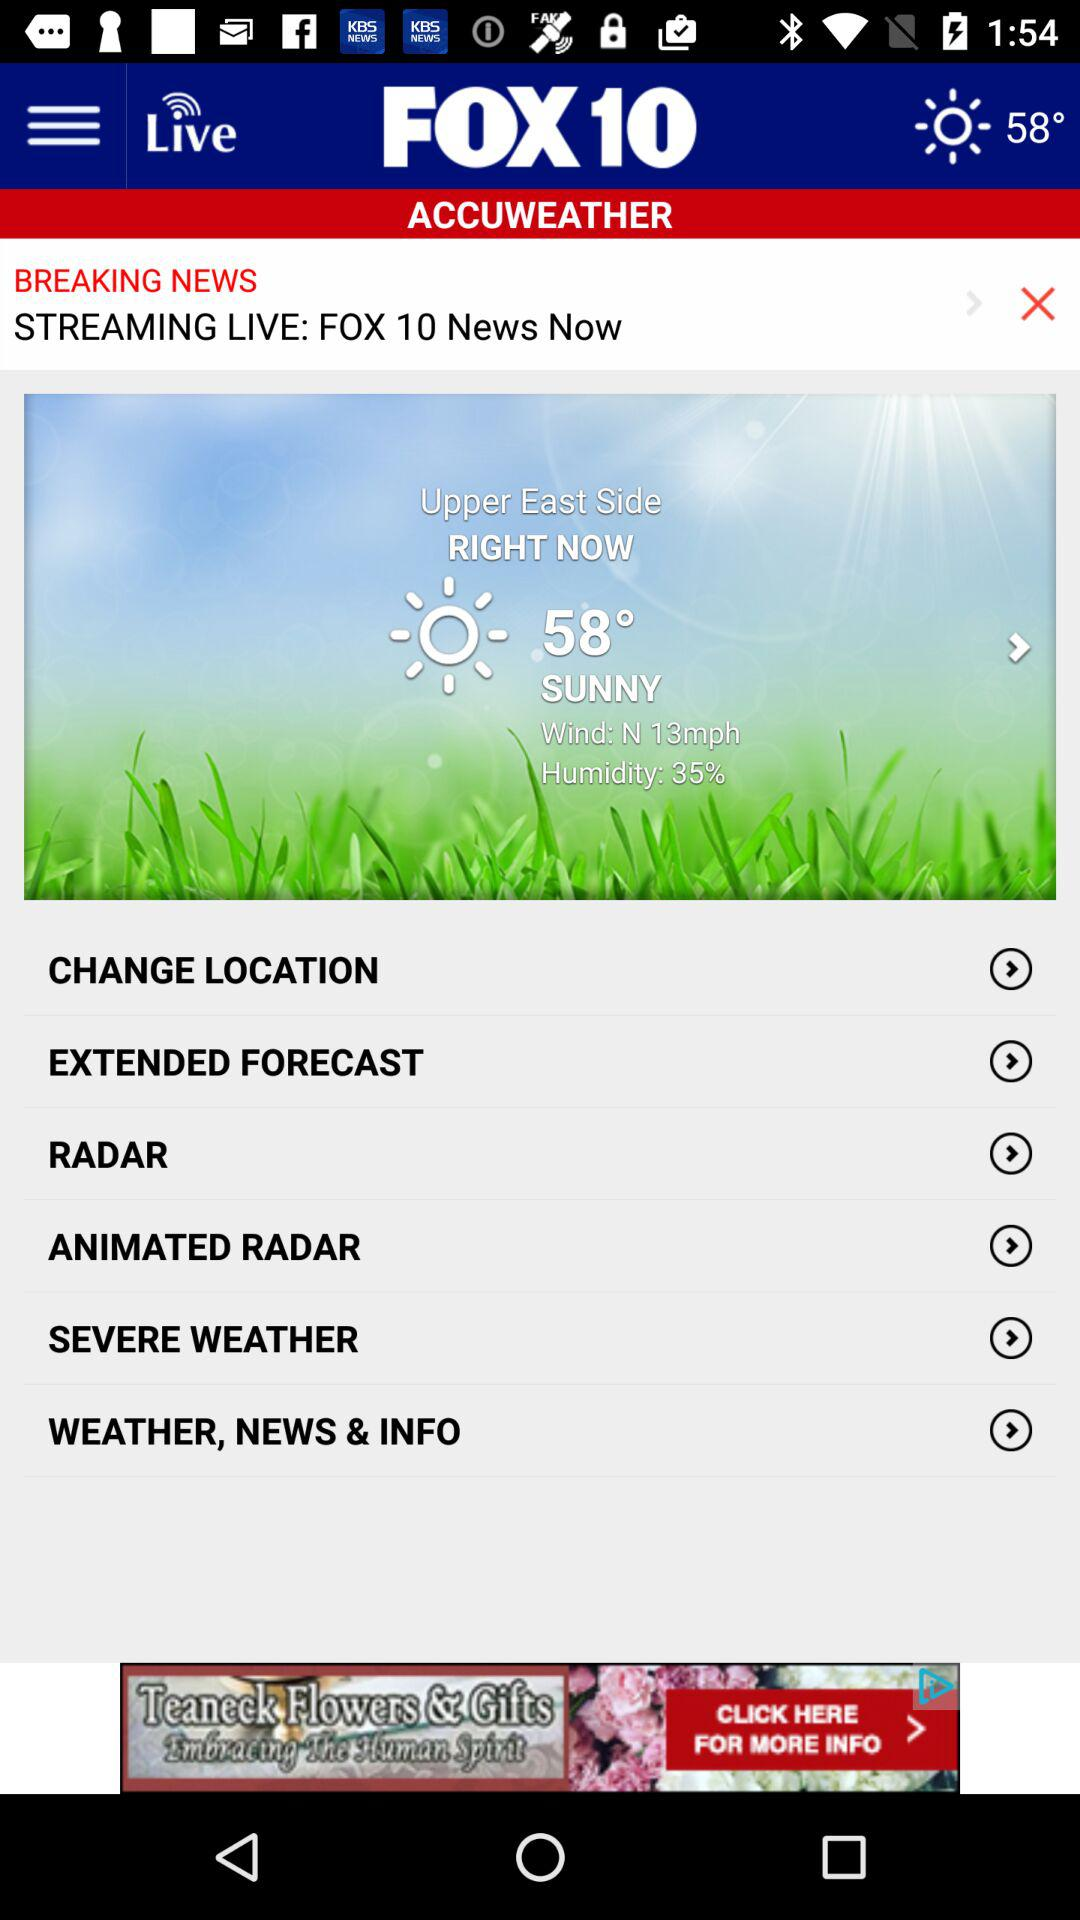How much is humidity? The humidity is 35%. 